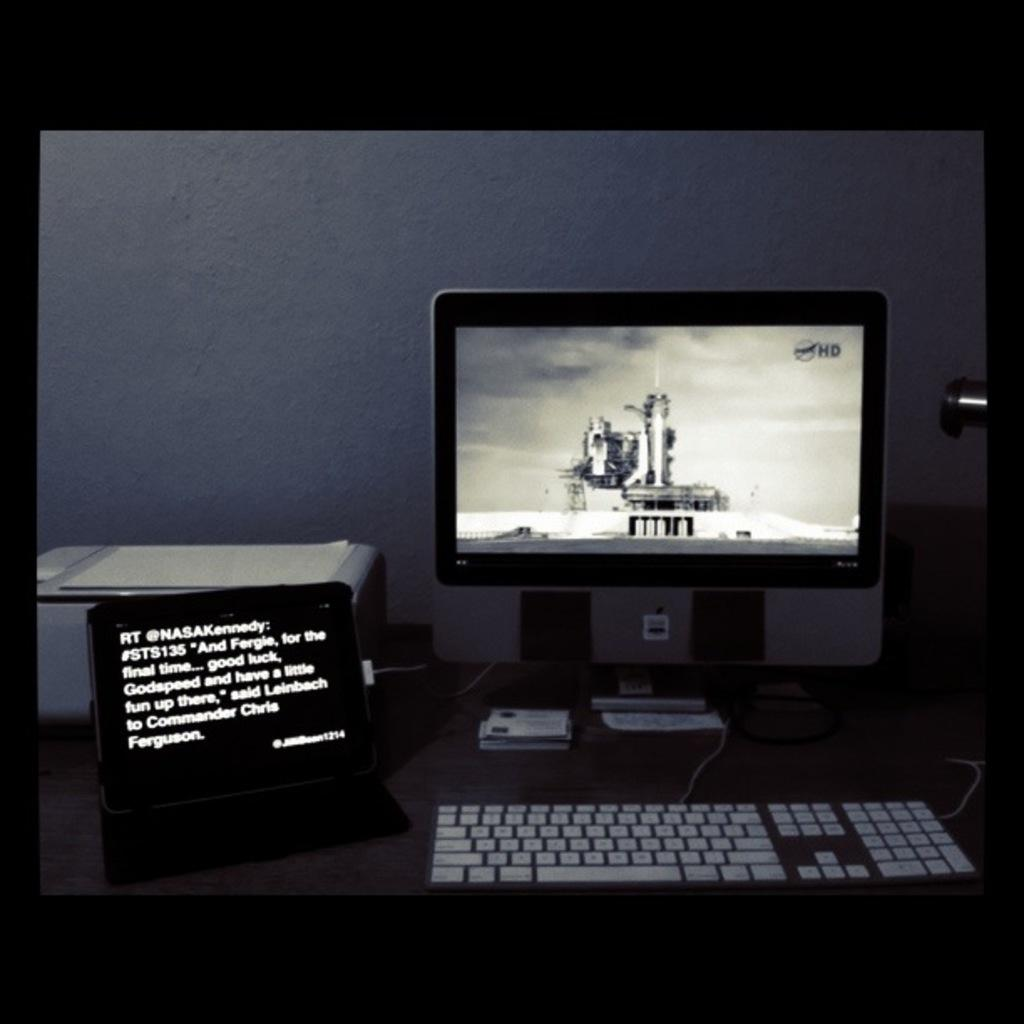<image>
Give a short and clear explanation of the subsequent image. A computer is on a desk next to a laptop that shows a quote from Leinbach to Commander Chris Ferguson. 